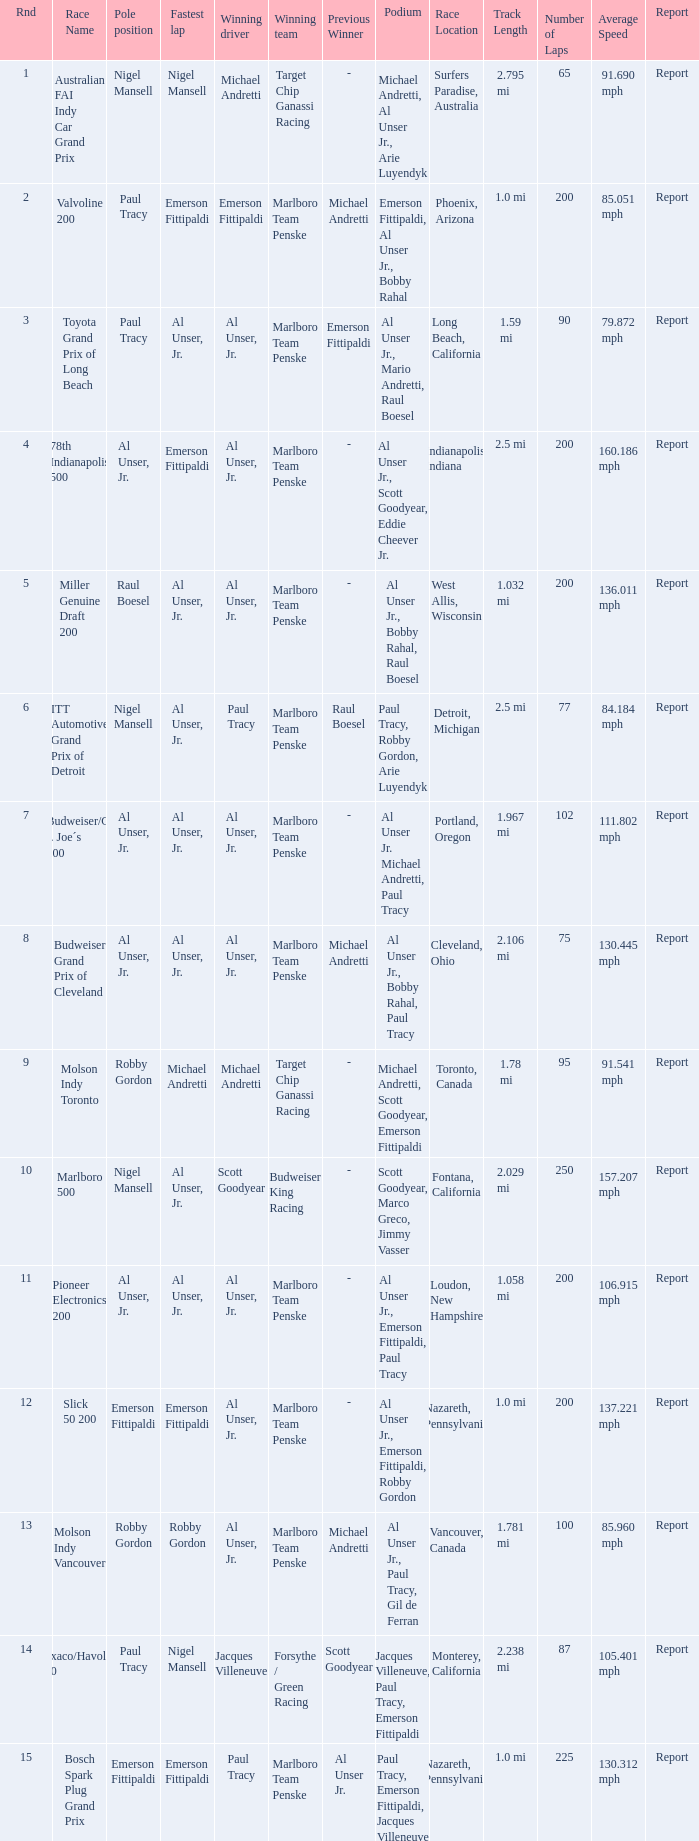Who was at the pole position in the ITT Automotive Grand Prix of Detroit, won by Paul Tracy? Nigel Mansell. 